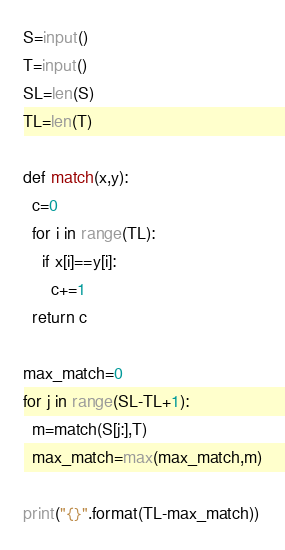<code> <loc_0><loc_0><loc_500><loc_500><_Python_>S=input()
T=input()
SL=len(S)
TL=len(T)

def match(x,y):
  c=0
  for i in range(TL):
    if x[i]==y[i]:
      c+=1
  return c

max_match=0
for j in range(SL-TL+1):
  m=match(S[j:],T)
  max_match=max(max_match,m)

print("{}".format(TL-max_match))</code> 